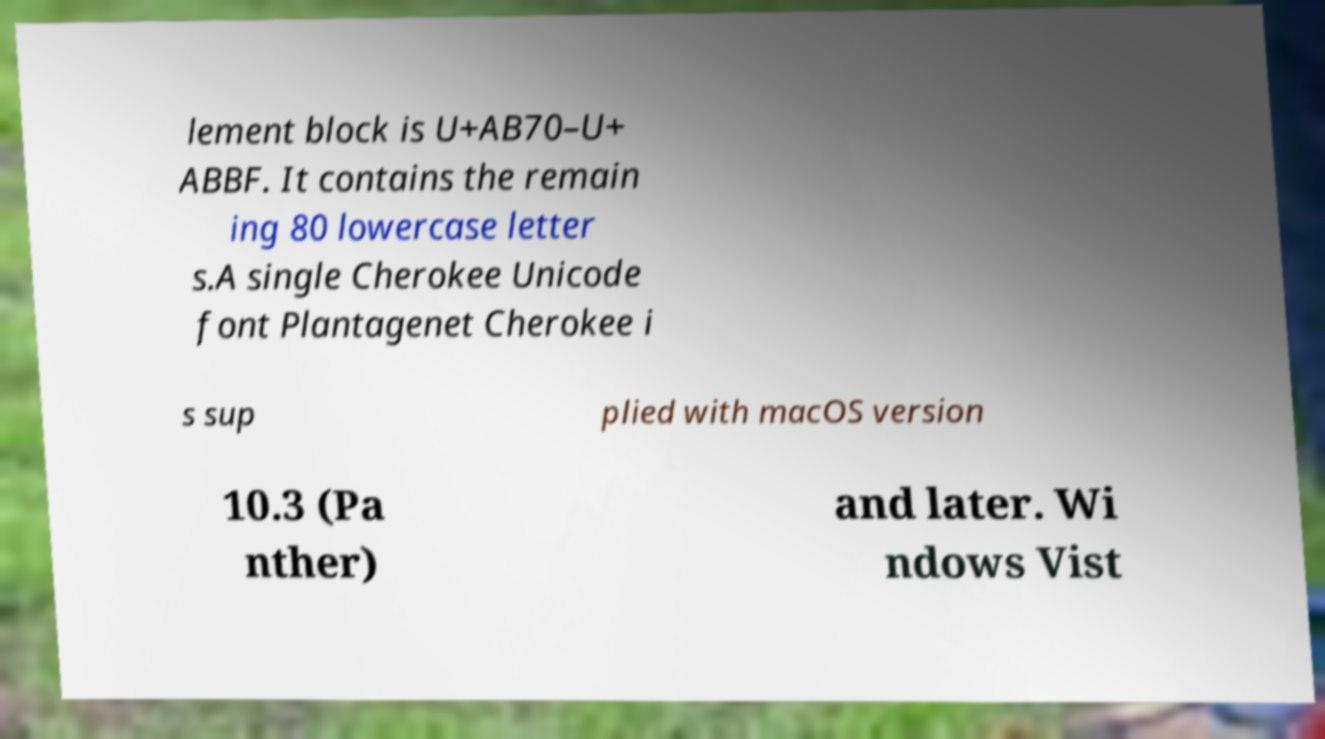There's text embedded in this image that I need extracted. Can you transcribe it verbatim? lement block is U+AB70–U+ ABBF. It contains the remain ing 80 lowercase letter s.A single Cherokee Unicode font Plantagenet Cherokee i s sup plied with macOS version 10.3 (Pa nther) and later. Wi ndows Vist 